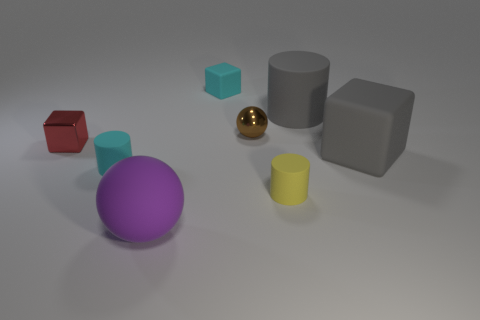Are the large cylinder and the yellow cylinder made of the same material? Although the image suggests they have a similar matte finish, without additional information, we cannot conclusively determine if the large gray cylinder and the smaller yellow cylinder are composed of the same material. Material properties can vary significantly beyond surface appearance. 